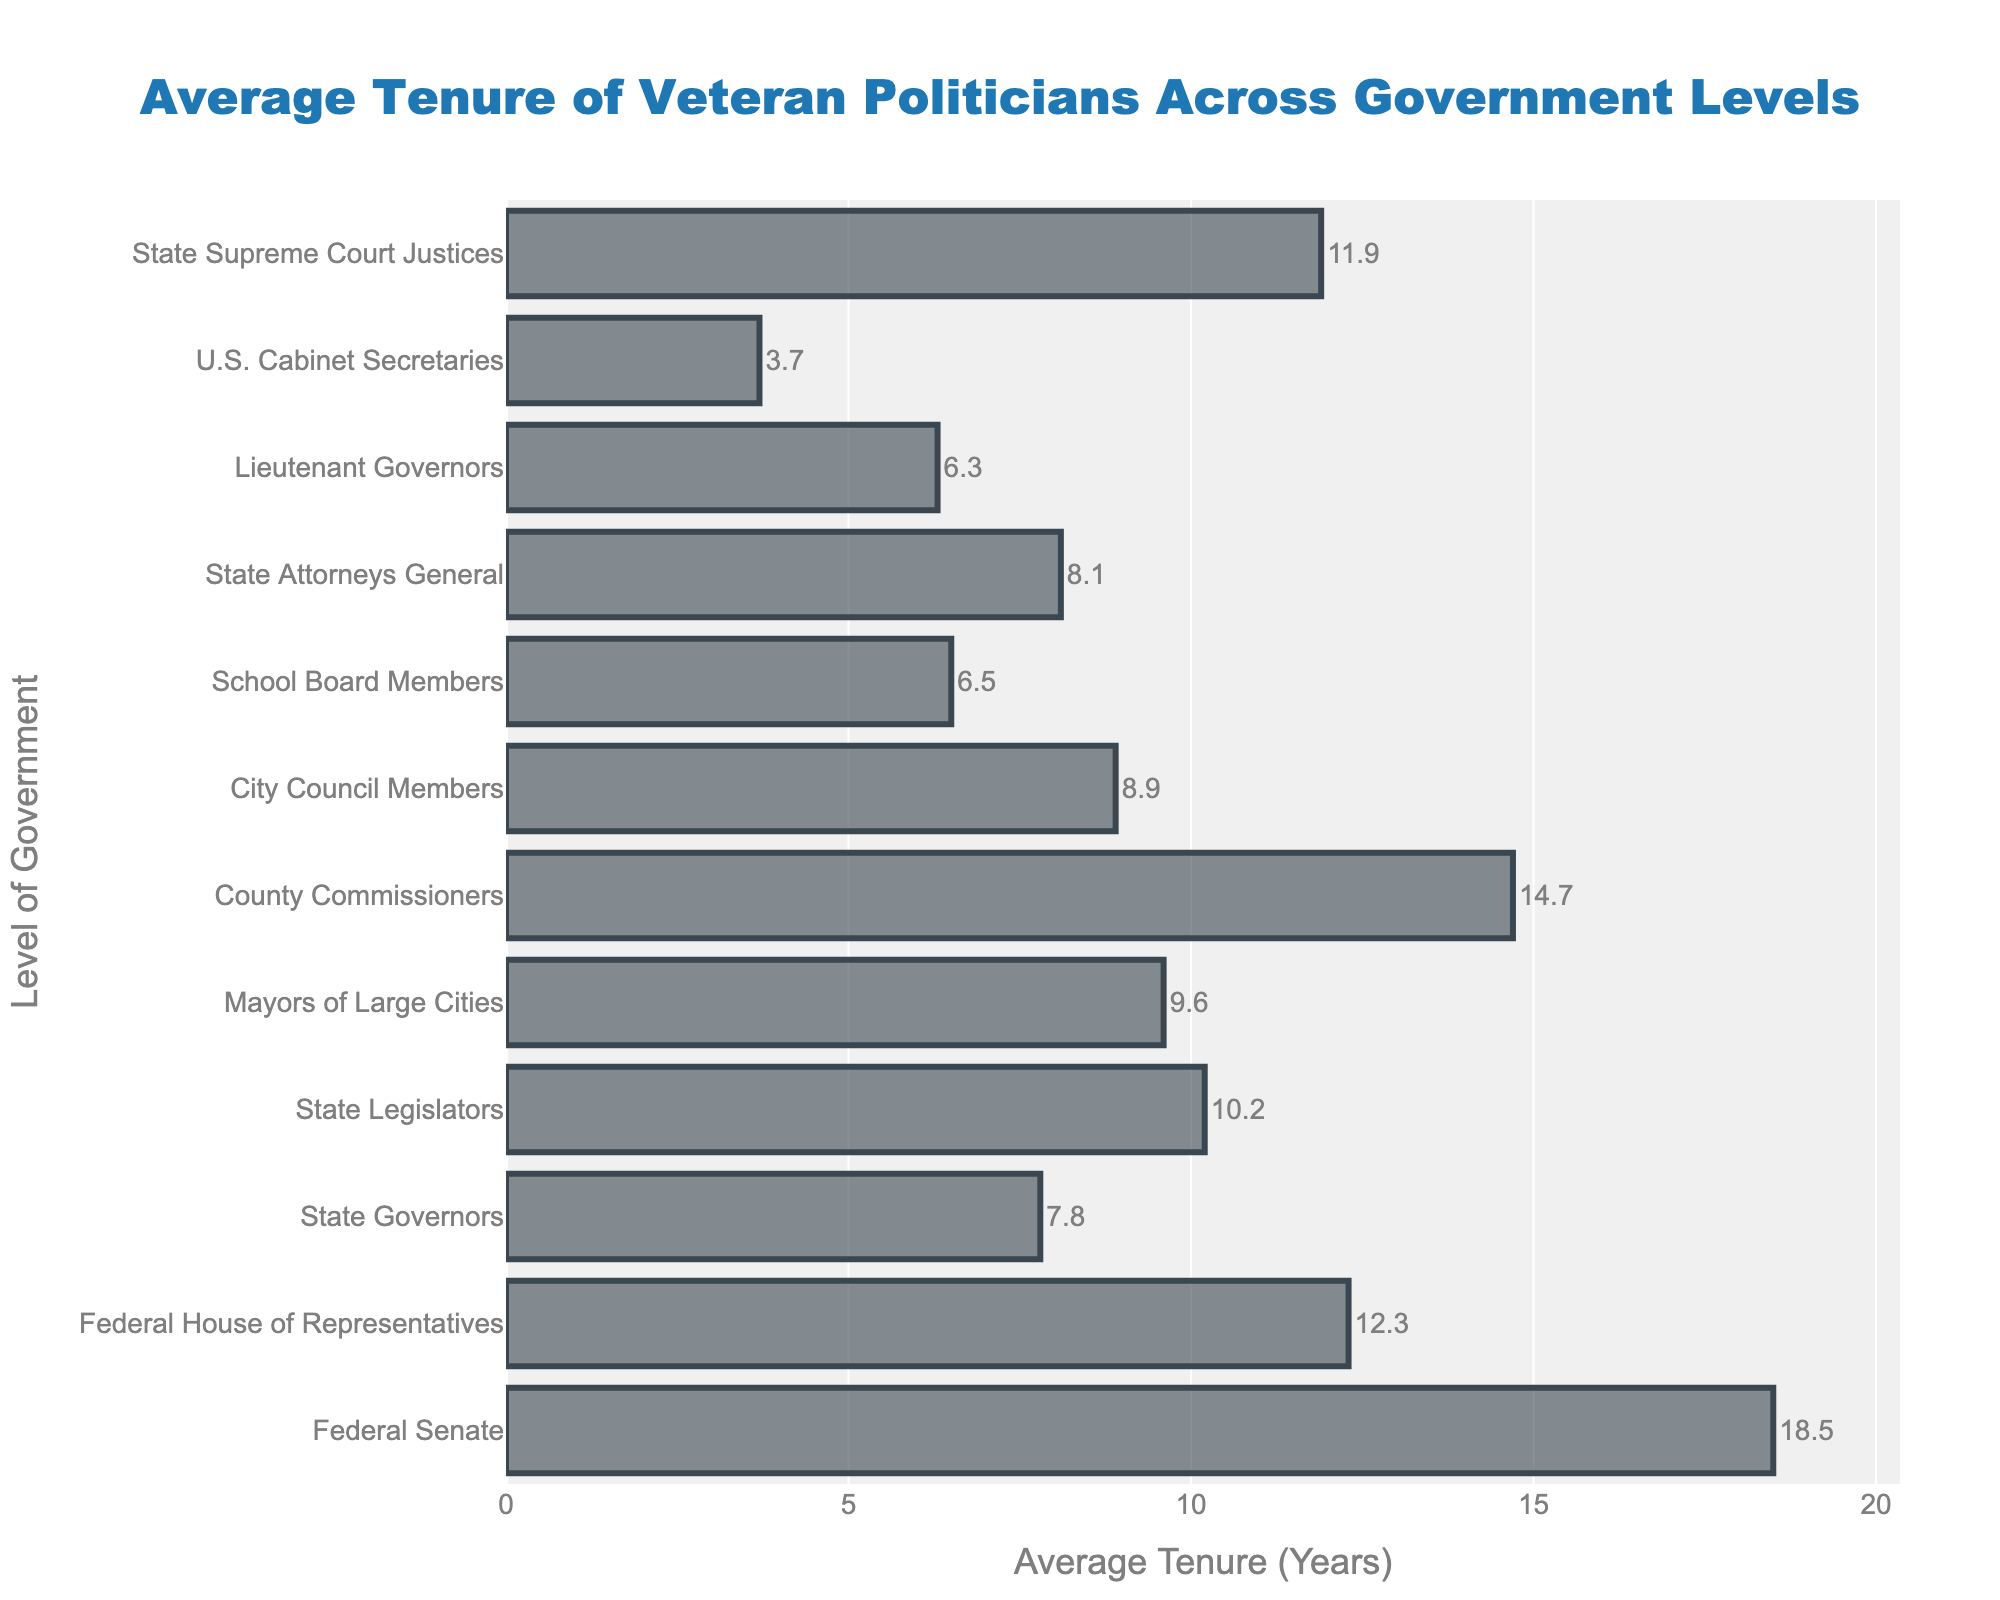Which level of government has the highest average tenure? The highest bar in the chart represents the level of government with the highest average tenure. The Federal Senate has the highest average tenure with 18.5 years.
Answer: Federal Senate Which two levels of government have the closest average tenures? Look at the lengths of the bars to find the two that are most similar in length. City Council Members (8.9 years) and State Attorneys General (8.1 years) have the closest tenures.
Answer: City Council Members and State Attorneys General How much longer, on average, is the tenure of Federal Senators compared to State Legislators? Subtract the average tenure of State Legislators from that of Federal Senators. Federal Senate is 18.5 years and State Legislators is 10.2 years. 18.5 - 10.2 = 8.3.
Answer: 8.3 years What's the average tenure difference between levels of government with the longest and shortest tenures? Subtract the shortest average tenure from the longest average tenure. Longest is Federal Senate (18.5 years), shortest is U.S. Cabinet Secretaries (3.7 years). 18.5 - 3.7 = 14.8.
Answer: 14.8 years What's the total average tenure of Mayors of Large Cities and County Commissioners combined? Add the average tenures of Mayors of Large Cities and County Commissioners. Mayors of Large Cities is 9.6 years, County Commissioners is 14.7 years. 9.6 + 14.7 = 24.3.
Answer: 24.3 years Which level of government has an average tenure longer than State Supreme Court Justices but shorter than Federal House of Representatives? Identify the tenure for State Supreme Court Justices (11.9 years) and Federal House of Representatives (12.3 years) and find the level of government with a tenure between these values. There is none that fits this criteria.
Answer: None What is the median average tenure of all levels of government listed? List all the average tenures, sort them, and find the median value. Sorted values are: 3.7, 6.3, 6.5, 7.8, 8.1, 8.9, 9.6, 10.2, 11.9, 12.3, 14.7, 18.5. The median is the average of the 6th and 7th values in the sorted list. (8.9 + 9.6) / 2 = 9.25.
Answer: 9.25 years Are City Council Members' average tenures longer than State Legislators'? Compare the average tenures directly. City Council Members have an average tenure of 8.9 years, State Legislators have an average tenure of 10.2 years. 8.9 is less than 10.2.
Answer: No 